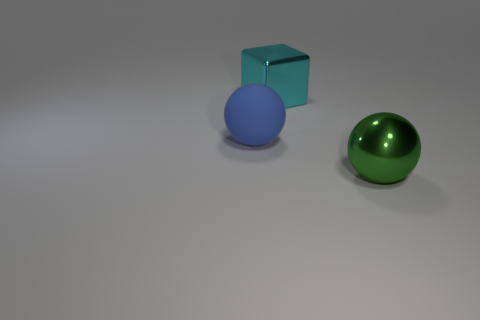How are the shadows in the image oriented, and what does this tell us about the light source? The shadows extend towards the left and slightly towards the bottom of the image, from their respective objects. This indicates that the light source is coming from the right, and slightly above the plane of the objects. The shadows are soft-edged, suggesting that the light source is not too close and could be diffused, simulating a real-world lighting environment commonly seen indoors. 